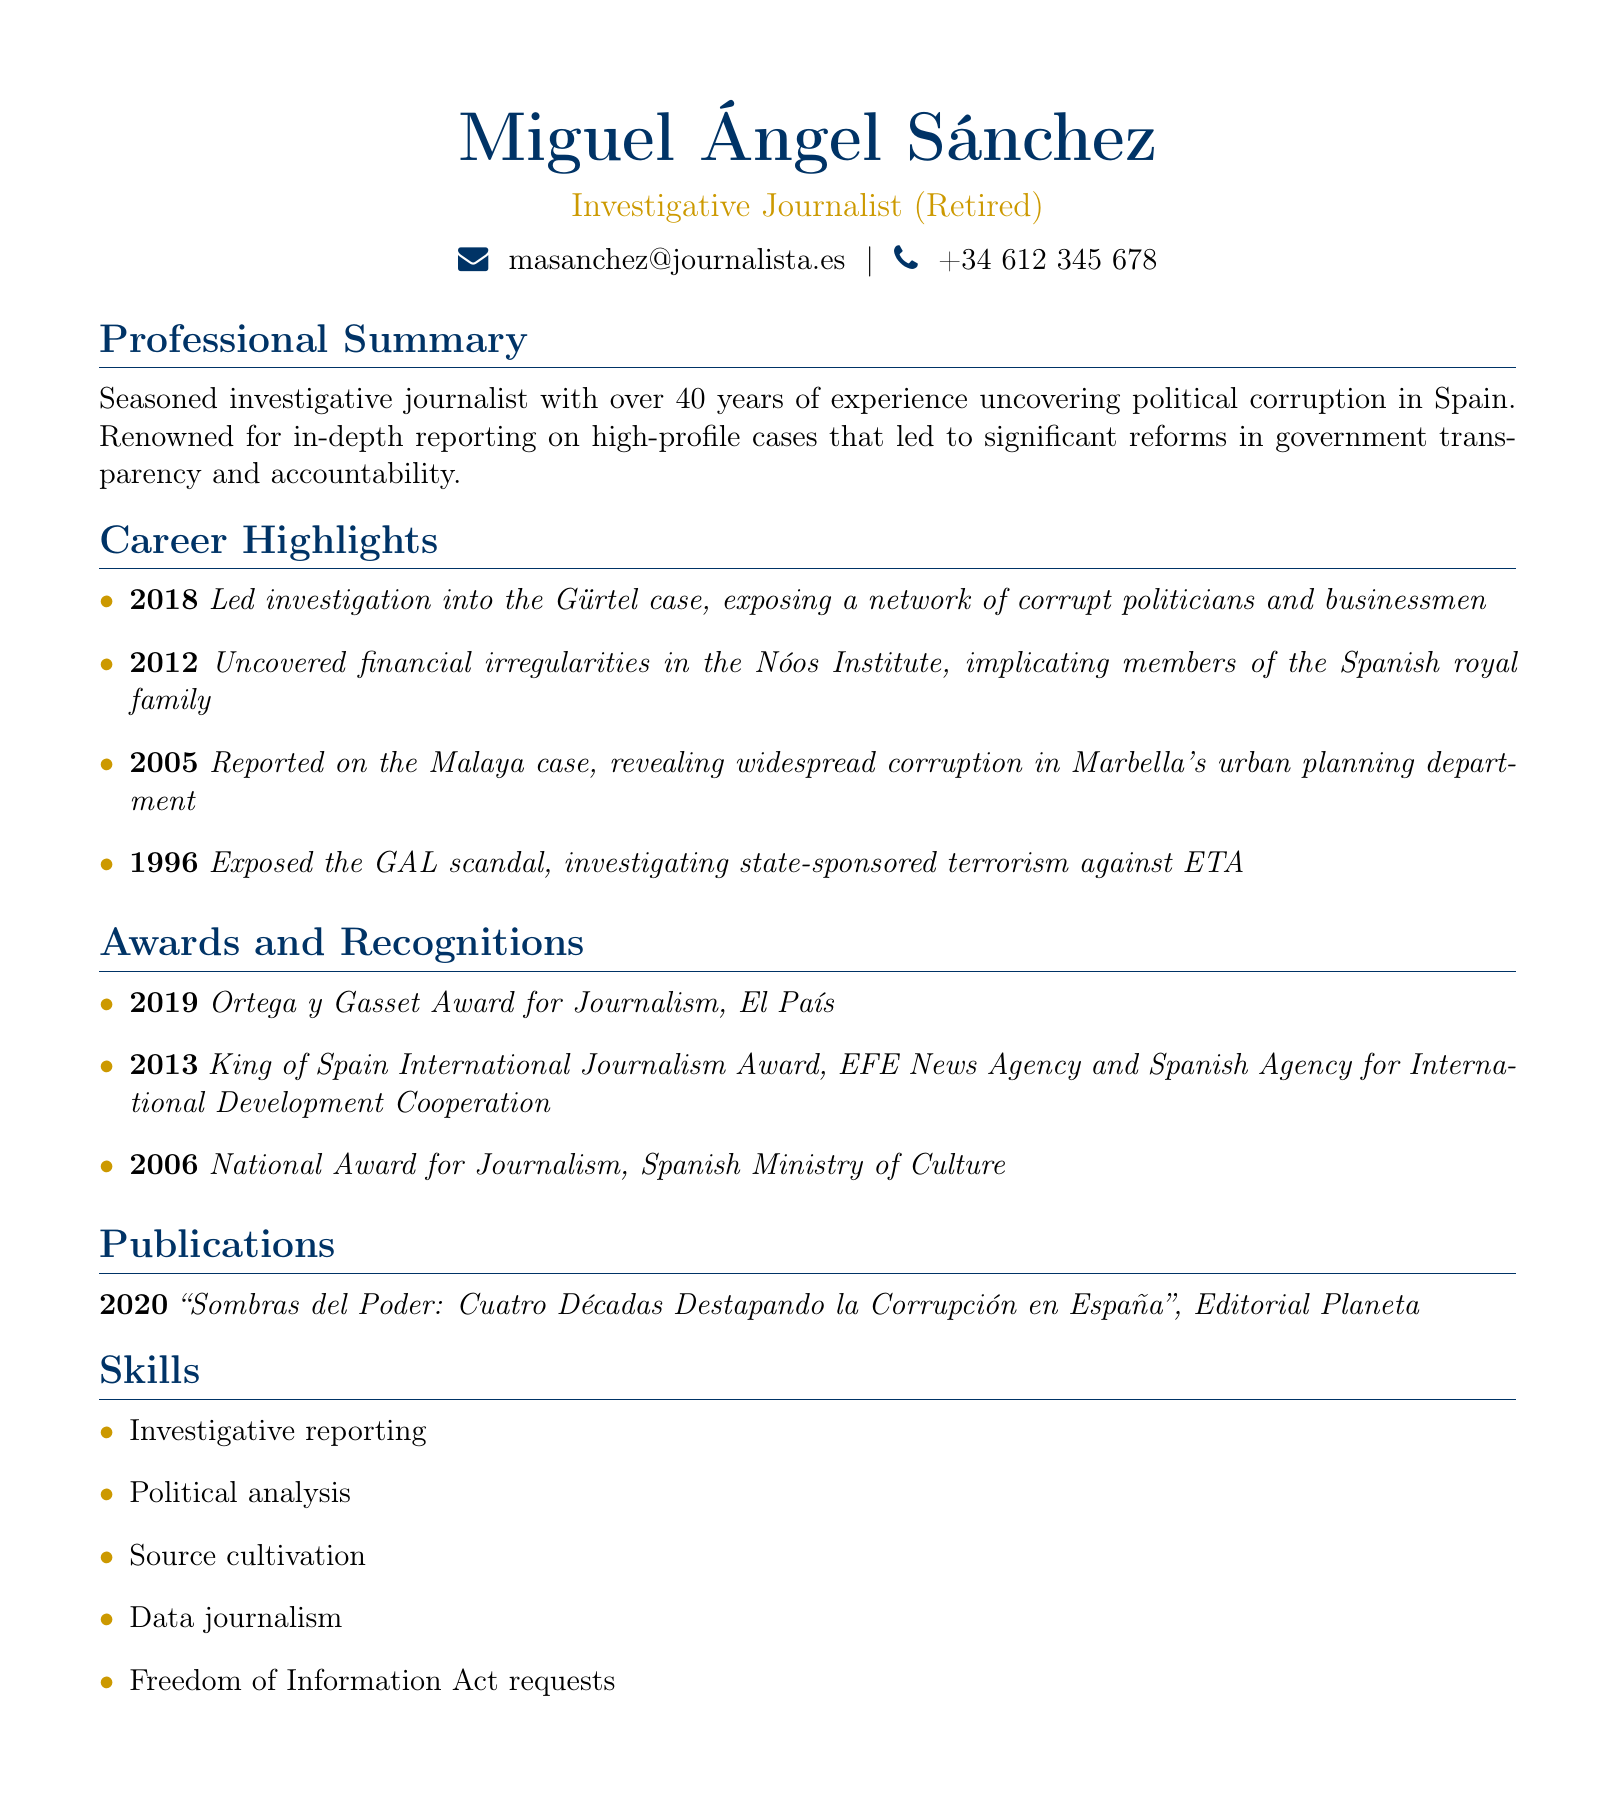What is the name of the journalist? The name is displayed prominently at the top of the document.
Answer: Miguel Ángel Sánchez In what year did Miguel Ángel Sánchez retire? The document indicates his status as a retired journalist but does not specify a retirement year.
Answer: Not specified What award did he receive in 2019? The awards section lists the specific achievements and their corresponding years.
Answer: Ortega y Gasset Award for Journalism Which case did he report on in 2012? The document provides a chronological list of career highlights, identifying notable investigations.
Answer: Nóos Institute How many awards has Miguel Ángel Sánchez received? The awards section lists three distinct achievements throughout his career.
Answer: Three What type of skills does Miguel Ángel Sánchez possess? The skills section enumerates the various competencies he has acquired over his career.
Answer: Investigative reporting What is the title of his publication from 2020? The publications section specifies the titles and the years they were published.
Answer: Sombras del Poder: Cuatro Décadas Destapando la Corrupción en España What major scandal was investigated in 1996? The career highlights relate significant scandals to the corresponding years of investigation.
Answer: GAL scandal 